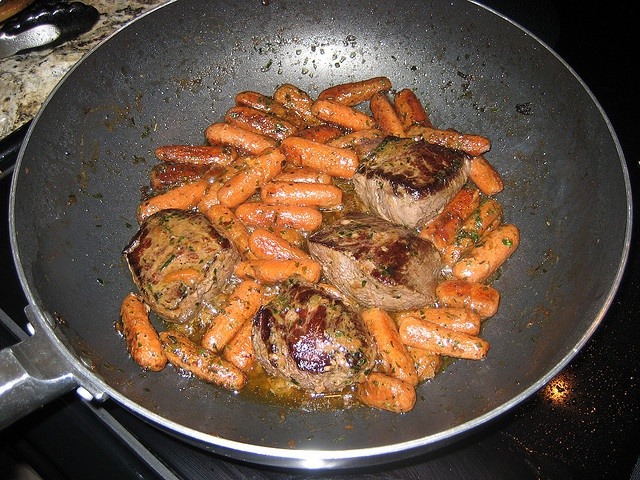Describe the objects in this image and their specific colors. I can see carrot in white, brown, red, and orange tones and oven in white, black, gray, and maroon tones in this image. 